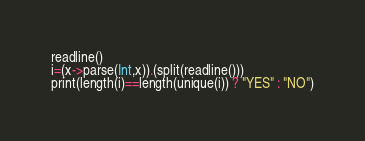<code> <loc_0><loc_0><loc_500><loc_500><_Julia_>readline()
i=(x->parse(Int,x)).(split(readline()))
print(length(i)==length(unique(i)) ? "YES" : "NO")</code> 